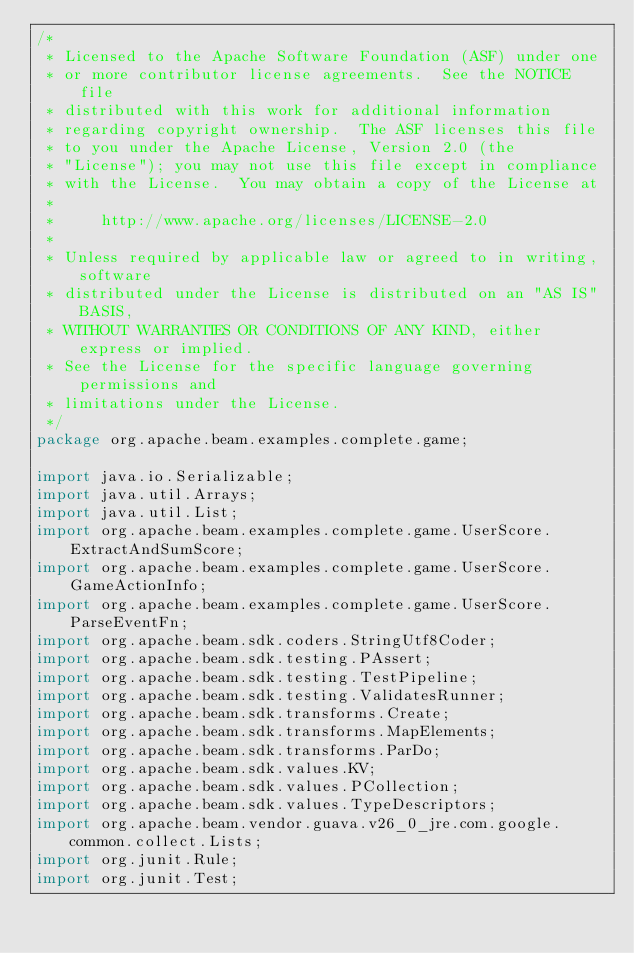<code> <loc_0><loc_0><loc_500><loc_500><_Java_>/*
 * Licensed to the Apache Software Foundation (ASF) under one
 * or more contributor license agreements.  See the NOTICE file
 * distributed with this work for additional information
 * regarding copyright ownership.  The ASF licenses this file
 * to you under the Apache License, Version 2.0 (the
 * "License"); you may not use this file except in compliance
 * with the License.  You may obtain a copy of the License at
 *
 *     http://www.apache.org/licenses/LICENSE-2.0
 *
 * Unless required by applicable law or agreed to in writing, software
 * distributed under the License is distributed on an "AS IS" BASIS,
 * WITHOUT WARRANTIES OR CONDITIONS OF ANY KIND, either express or implied.
 * See the License for the specific language governing permissions and
 * limitations under the License.
 */
package org.apache.beam.examples.complete.game;

import java.io.Serializable;
import java.util.Arrays;
import java.util.List;
import org.apache.beam.examples.complete.game.UserScore.ExtractAndSumScore;
import org.apache.beam.examples.complete.game.UserScore.GameActionInfo;
import org.apache.beam.examples.complete.game.UserScore.ParseEventFn;
import org.apache.beam.sdk.coders.StringUtf8Coder;
import org.apache.beam.sdk.testing.PAssert;
import org.apache.beam.sdk.testing.TestPipeline;
import org.apache.beam.sdk.testing.ValidatesRunner;
import org.apache.beam.sdk.transforms.Create;
import org.apache.beam.sdk.transforms.MapElements;
import org.apache.beam.sdk.transforms.ParDo;
import org.apache.beam.sdk.values.KV;
import org.apache.beam.sdk.values.PCollection;
import org.apache.beam.sdk.values.TypeDescriptors;
import org.apache.beam.vendor.guava.v26_0_jre.com.google.common.collect.Lists;
import org.junit.Rule;
import org.junit.Test;</code> 